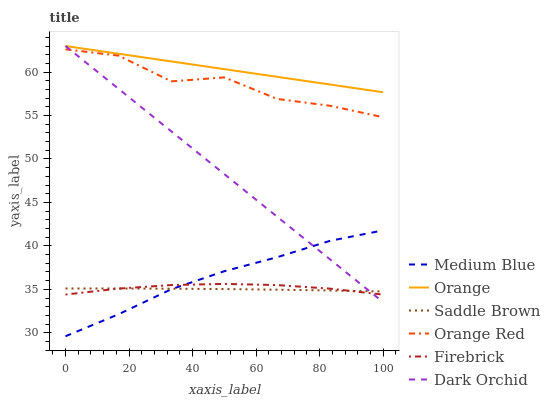Does Saddle Brown have the minimum area under the curve?
Answer yes or no. Yes. Does Orange have the maximum area under the curve?
Answer yes or no. Yes. Does Medium Blue have the minimum area under the curve?
Answer yes or no. No. Does Medium Blue have the maximum area under the curve?
Answer yes or no. No. Is Orange the smoothest?
Answer yes or no. Yes. Is Orange Red the roughest?
Answer yes or no. Yes. Is Medium Blue the smoothest?
Answer yes or no. No. Is Medium Blue the roughest?
Answer yes or no. No. Does Medium Blue have the lowest value?
Answer yes or no. Yes. Does Dark Orchid have the lowest value?
Answer yes or no. No. Does Orange have the highest value?
Answer yes or no. Yes. Does Medium Blue have the highest value?
Answer yes or no. No. Is Firebrick less than Orange?
Answer yes or no. Yes. Is Orange greater than Saddle Brown?
Answer yes or no. Yes. Does Dark Orchid intersect Saddle Brown?
Answer yes or no. Yes. Is Dark Orchid less than Saddle Brown?
Answer yes or no. No. Is Dark Orchid greater than Saddle Brown?
Answer yes or no. No. Does Firebrick intersect Orange?
Answer yes or no. No. 